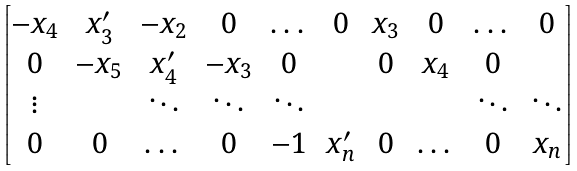<formula> <loc_0><loc_0><loc_500><loc_500>\begin{bmatrix} - x _ { 4 } & x ^ { \prime } _ { 3 } & - x _ { 2 } & 0 & \dots & 0 & x _ { 3 } & 0 & \dots & 0 \\ 0 & - x _ { 5 } & x ^ { \prime } _ { 4 } & - x _ { 3 } & 0 & & 0 & x _ { 4 } & 0 & \\ \vdots & & \ddots & \ddots & \ddots & & & & \ddots & \ddots \\ 0 & 0 & \dots & 0 & - 1 & x ^ { \prime } _ { n } & 0 & \dots & 0 & x _ { n } \end{bmatrix}</formula> 